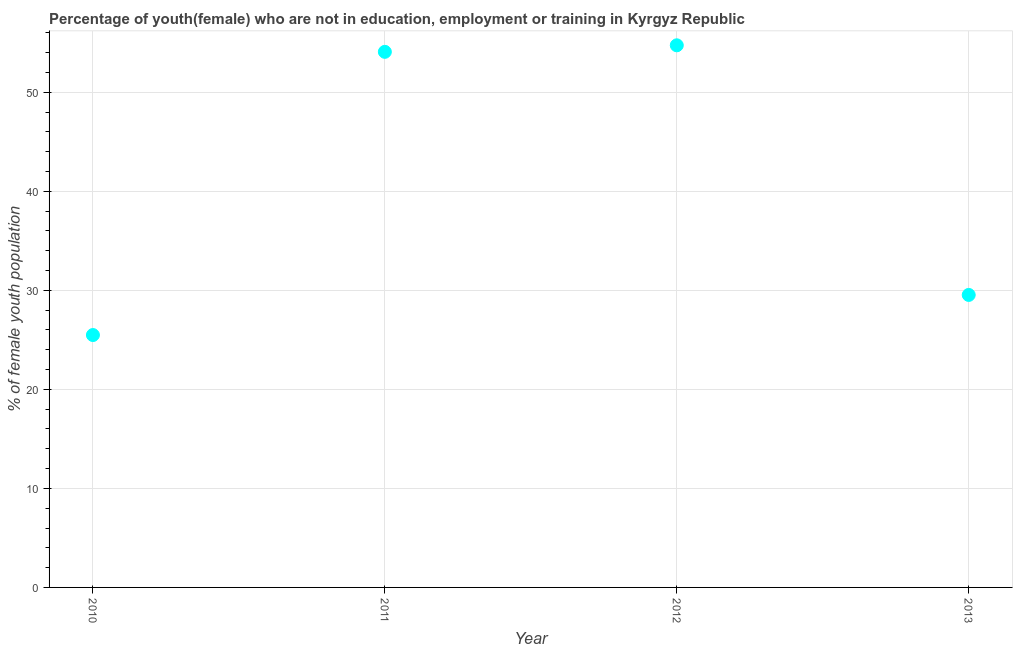What is the unemployed female youth population in 2010?
Offer a very short reply. 25.49. Across all years, what is the maximum unemployed female youth population?
Provide a short and direct response. 54.75. Across all years, what is the minimum unemployed female youth population?
Offer a very short reply. 25.49. In which year was the unemployed female youth population maximum?
Give a very brief answer. 2012. What is the sum of the unemployed female youth population?
Offer a terse response. 163.87. What is the difference between the unemployed female youth population in 2010 and 2011?
Your response must be concise. -28.6. What is the average unemployed female youth population per year?
Give a very brief answer. 40.97. What is the median unemployed female youth population?
Your response must be concise. 41.82. In how many years, is the unemployed female youth population greater than 12 %?
Your answer should be very brief. 4. What is the ratio of the unemployed female youth population in 2010 to that in 2012?
Provide a short and direct response. 0.47. What is the difference between the highest and the second highest unemployed female youth population?
Make the answer very short. 0.66. Is the sum of the unemployed female youth population in 2012 and 2013 greater than the maximum unemployed female youth population across all years?
Give a very brief answer. Yes. What is the difference between the highest and the lowest unemployed female youth population?
Your response must be concise. 29.26. How many years are there in the graph?
Provide a succinct answer. 4. What is the difference between two consecutive major ticks on the Y-axis?
Your answer should be very brief. 10. Are the values on the major ticks of Y-axis written in scientific E-notation?
Your response must be concise. No. Does the graph contain grids?
Keep it short and to the point. Yes. What is the title of the graph?
Your answer should be very brief. Percentage of youth(female) who are not in education, employment or training in Kyrgyz Republic. What is the label or title of the Y-axis?
Give a very brief answer. % of female youth population. What is the % of female youth population in 2010?
Ensure brevity in your answer.  25.49. What is the % of female youth population in 2011?
Give a very brief answer. 54.09. What is the % of female youth population in 2012?
Offer a very short reply. 54.75. What is the % of female youth population in 2013?
Your answer should be very brief. 29.54. What is the difference between the % of female youth population in 2010 and 2011?
Your answer should be compact. -28.6. What is the difference between the % of female youth population in 2010 and 2012?
Provide a short and direct response. -29.26. What is the difference between the % of female youth population in 2010 and 2013?
Provide a succinct answer. -4.05. What is the difference between the % of female youth population in 2011 and 2012?
Offer a very short reply. -0.66. What is the difference between the % of female youth population in 2011 and 2013?
Keep it short and to the point. 24.55. What is the difference between the % of female youth population in 2012 and 2013?
Provide a succinct answer. 25.21. What is the ratio of the % of female youth population in 2010 to that in 2011?
Give a very brief answer. 0.47. What is the ratio of the % of female youth population in 2010 to that in 2012?
Your response must be concise. 0.47. What is the ratio of the % of female youth population in 2010 to that in 2013?
Offer a terse response. 0.86. What is the ratio of the % of female youth population in 2011 to that in 2012?
Keep it short and to the point. 0.99. What is the ratio of the % of female youth population in 2011 to that in 2013?
Ensure brevity in your answer.  1.83. What is the ratio of the % of female youth population in 2012 to that in 2013?
Offer a very short reply. 1.85. 